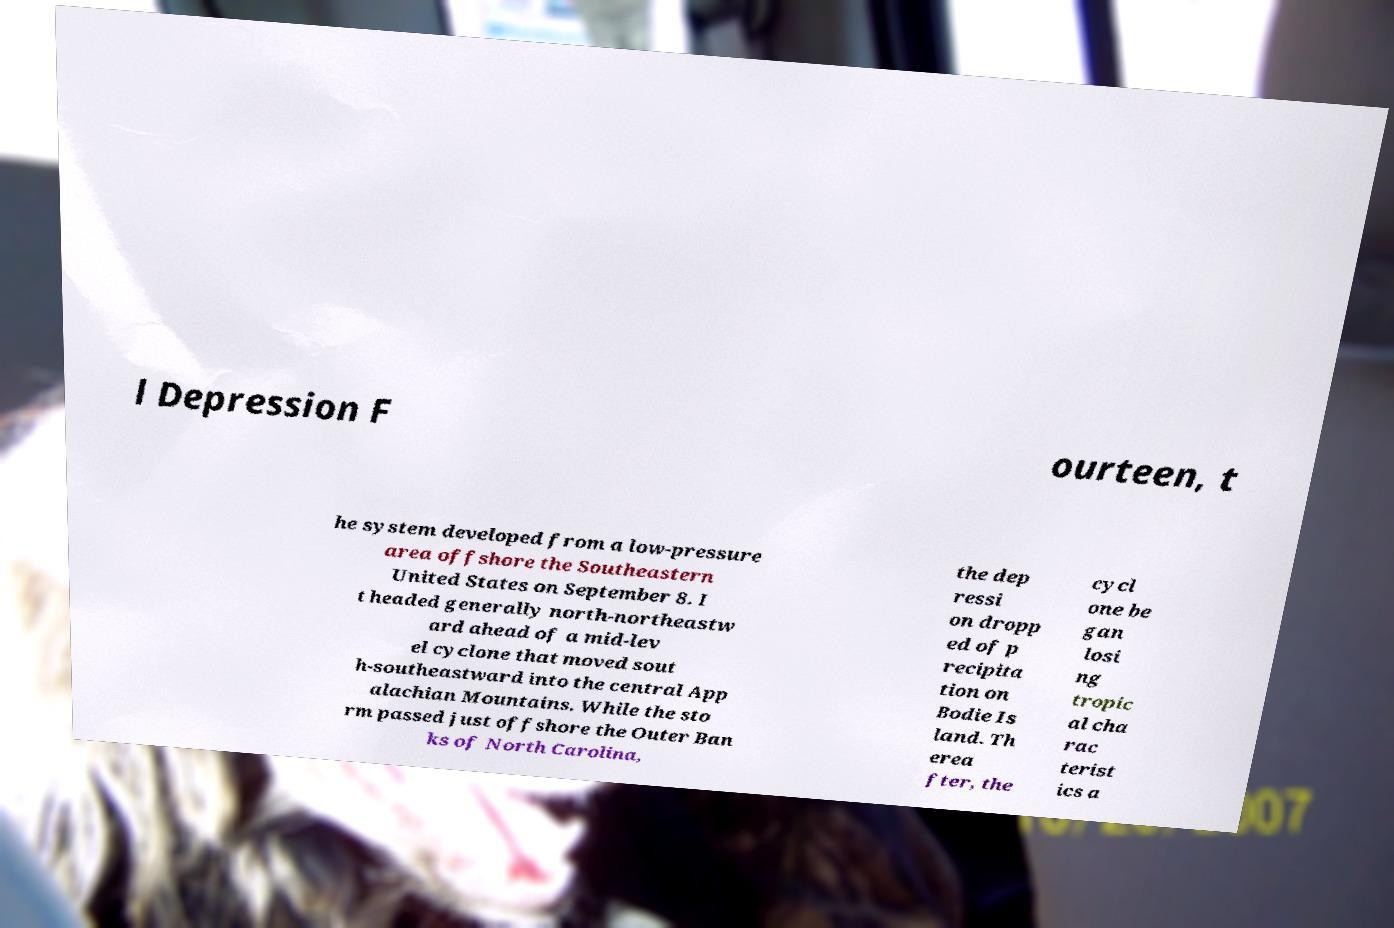Could you assist in decoding the text presented in this image and type it out clearly? l Depression F ourteen, t he system developed from a low-pressure area offshore the Southeastern United States on September 8. I t headed generally north-northeastw ard ahead of a mid-lev el cyclone that moved sout h-southeastward into the central App alachian Mountains. While the sto rm passed just offshore the Outer Ban ks of North Carolina, the dep ressi on dropp ed of p recipita tion on Bodie Is land. Th erea fter, the cycl one be gan losi ng tropic al cha rac terist ics a 